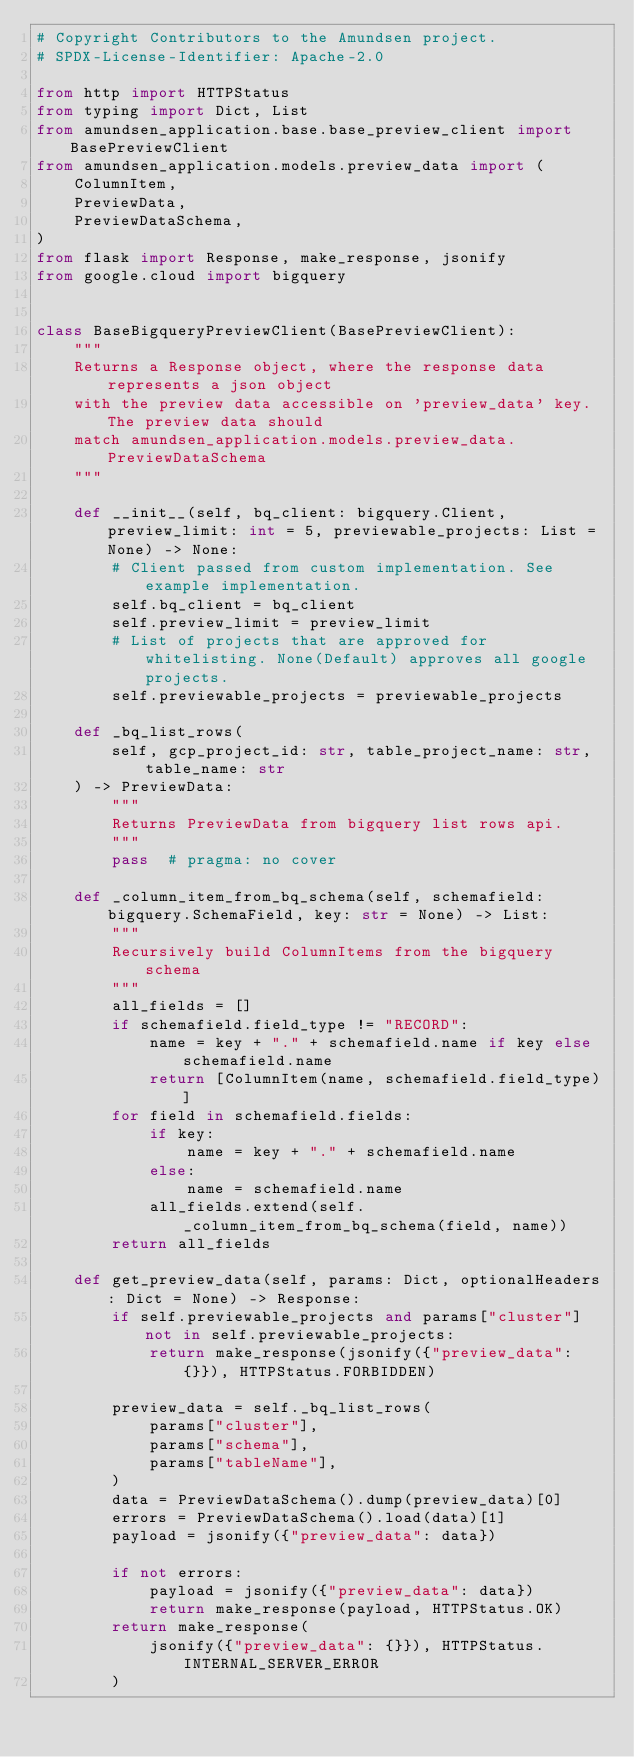<code> <loc_0><loc_0><loc_500><loc_500><_Python_># Copyright Contributors to the Amundsen project.
# SPDX-License-Identifier: Apache-2.0

from http import HTTPStatus
from typing import Dict, List
from amundsen_application.base.base_preview_client import BasePreviewClient
from amundsen_application.models.preview_data import (
    ColumnItem,
    PreviewData,
    PreviewDataSchema,
)
from flask import Response, make_response, jsonify
from google.cloud import bigquery


class BaseBigqueryPreviewClient(BasePreviewClient):
    """
    Returns a Response object, where the response data represents a json object
    with the preview data accessible on 'preview_data' key. The preview data should
    match amundsen_application.models.preview_data.PreviewDataSchema
    """

    def __init__(self, bq_client: bigquery.Client, preview_limit: int = 5, previewable_projects: List = None) -> None:
        # Client passed from custom implementation. See example implementation.
        self.bq_client = bq_client
        self.preview_limit = preview_limit
        # List of projects that are approved for whitelisting. None(Default) approves all google projects.
        self.previewable_projects = previewable_projects

    def _bq_list_rows(
        self, gcp_project_id: str, table_project_name: str, table_name: str
    ) -> PreviewData:
        """
        Returns PreviewData from bigquery list rows api.
        """
        pass  # pragma: no cover

    def _column_item_from_bq_schema(self, schemafield: bigquery.SchemaField, key: str = None) -> List:
        """
        Recursively build ColumnItems from the bigquery schema
        """
        all_fields = []
        if schemafield.field_type != "RECORD":
            name = key + "." + schemafield.name if key else schemafield.name
            return [ColumnItem(name, schemafield.field_type)]
        for field in schemafield.fields:
            if key:
                name = key + "." + schemafield.name
            else:
                name = schemafield.name
            all_fields.extend(self._column_item_from_bq_schema(field, name))
        return all_fields

    def get_preview_data(self, params: Dict, optionalHeaders: Dict = None) -> Response:
        if self.previewable_projects and params["cluster"] not in self.previewable_projects:
            return make_response(jsonify({"preview_data": {}}), HTTPStatus.FORBIDDEN)

        preview_data = self._bq_list_rows(
            params["cluster"],
            params["schema"],
            params["tableName"],
        )
        data = PreviewDataSchema().dump(preview_data)[0]
        errors = PreviewDataSchema().load(data)[1]
        payload = jsonify({"preview_data": data})

        if not errors:
            payload = jsonify({"preview_data": data})
            return make_response(payload, HTTPStatus.OK)
        return make_response(
            jsonify({"preview_data": {}}), HTTPStatus.INTERNAL_SERVER_ERROR
        )
</code> 